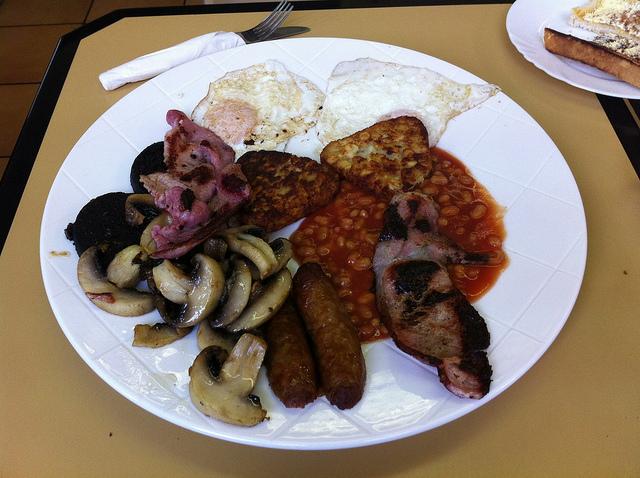Which meal of the day is this?
Quick response, please. Breakfast. Are there mushrooms on the plate?
Short answer required. Yes. What is the meat on the right in?
Quick response, please. Beans. 